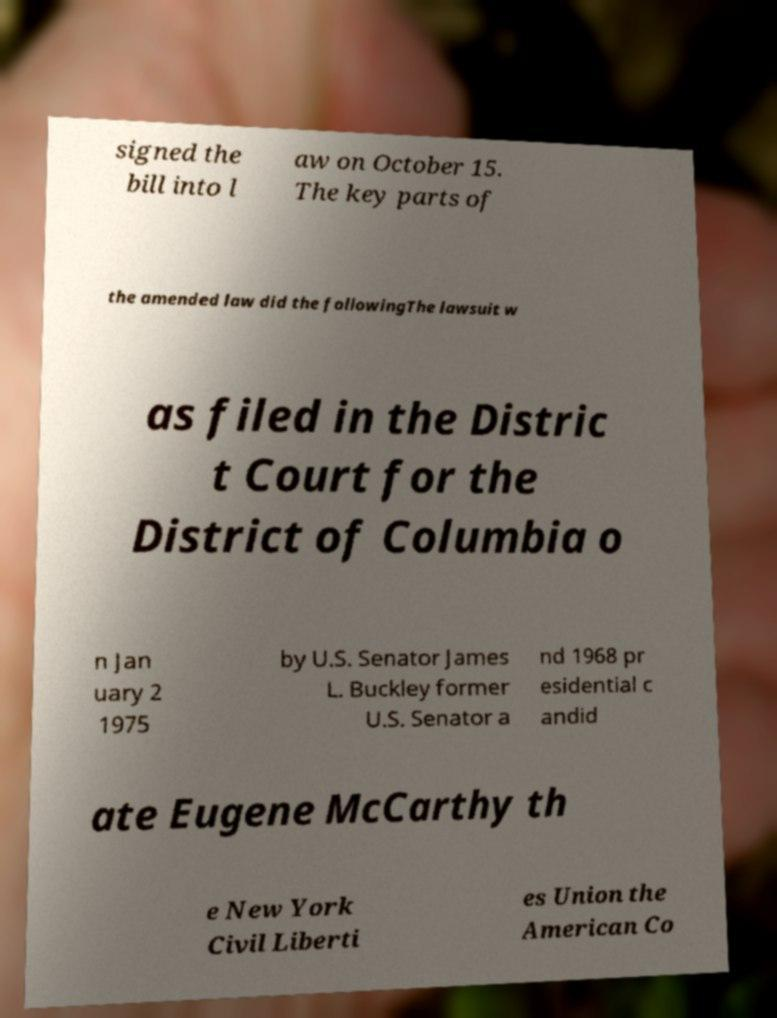Please identify and transcribe the text found in this image. signed the bill into l aw on October 15. The key parts of the amended law did the followingThe lawsuit w as filed in the Distric t Court for the District of Columbia o n Jan uary 2 1975 by U.S. Senator James L. Buckley former U.S. Senator a nd 1968 pr esidential c andid ate Eugene McCarthy th e New York Civil Liberti es Union the American Co 